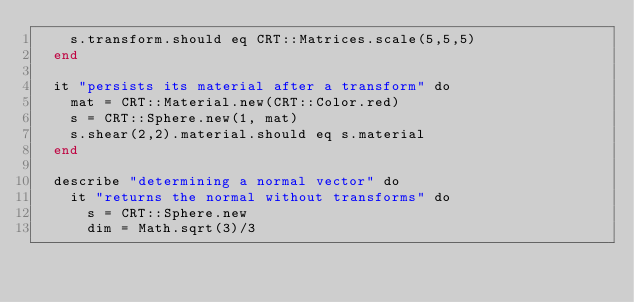<code> <loc_0><loc_0><loc_500><loc_500><_Crystal_>    s.transform.should eq CRT::Matrices.scale(5,5,5)
  end

  it "persists its material after a transform" do
    mat = CRT::Material.new(CRT::Color.red)
    s = CRT::Sphere.new(1, mat)
    s.shear(2,2).material.should eq s.material
  end

  describe "determining a normal vector" do
    it "returns the normal without transforms" do
      s = CRT::Sphere.new
      dim = Math.sqrt(3)/3</code> 